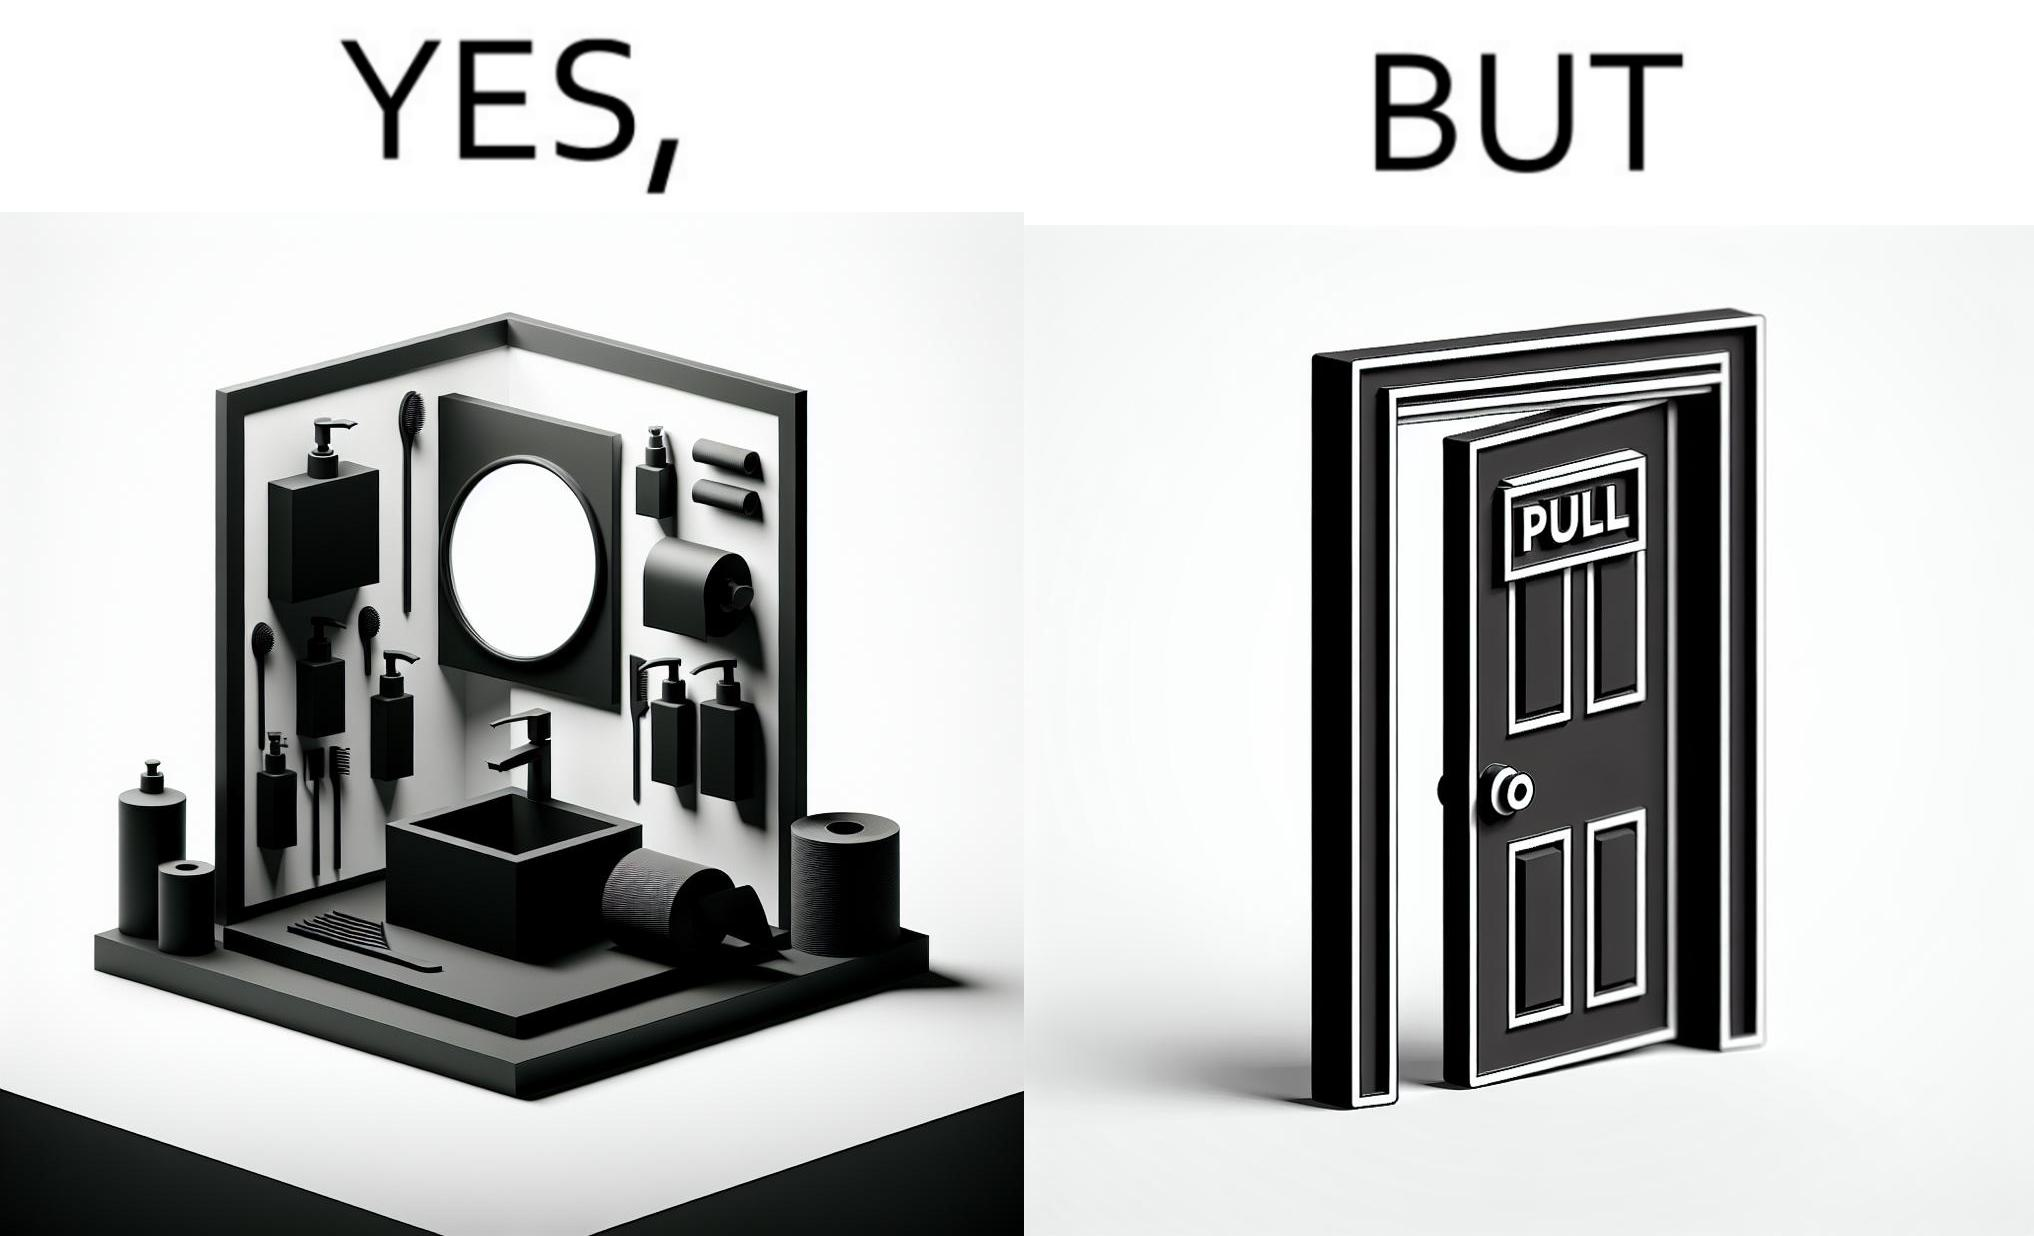What makes this image funny or satirical? The image is ironic, because in the first image in the bathroom there are so many things to clean hands around the basin but in the same bathroom people have to open the doors by hand which can easily spread the germs or bacteria even after times of hand cleaning as there is no way to open it without hands 